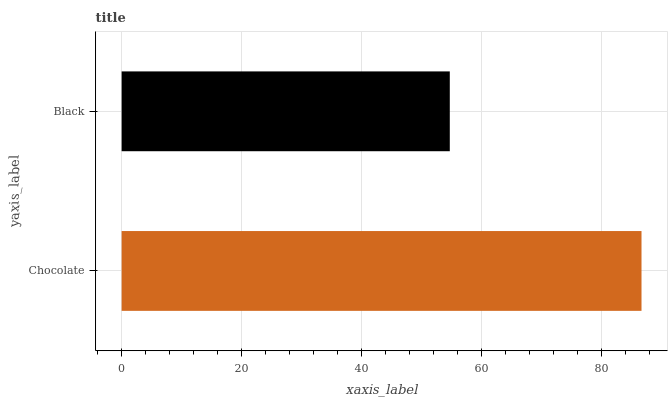Is Black the minimum?
Answer yes or no. Yes. Is Chocolate the maximum?
Answer yes or no. Yes. Is Black the maximum?
Answer yes or no. No. Is Chocolate greater than Black?
Answer yes or no. Yes. Is Black less than Chocolate?
Answer yes or no. Yes. Is Black greater than Chocolate?
Answer yes or no. No. Is Chocolate less than Black?
Answer yes or no. No. Is Chocolate the high median?
Answer yes or no. Yes. Is Black the low median?
Answer yes or no. Yes. Is Black the high median?
Answer yes or no. No. Is Chocolate the low median?
Answer yes or no. No. 